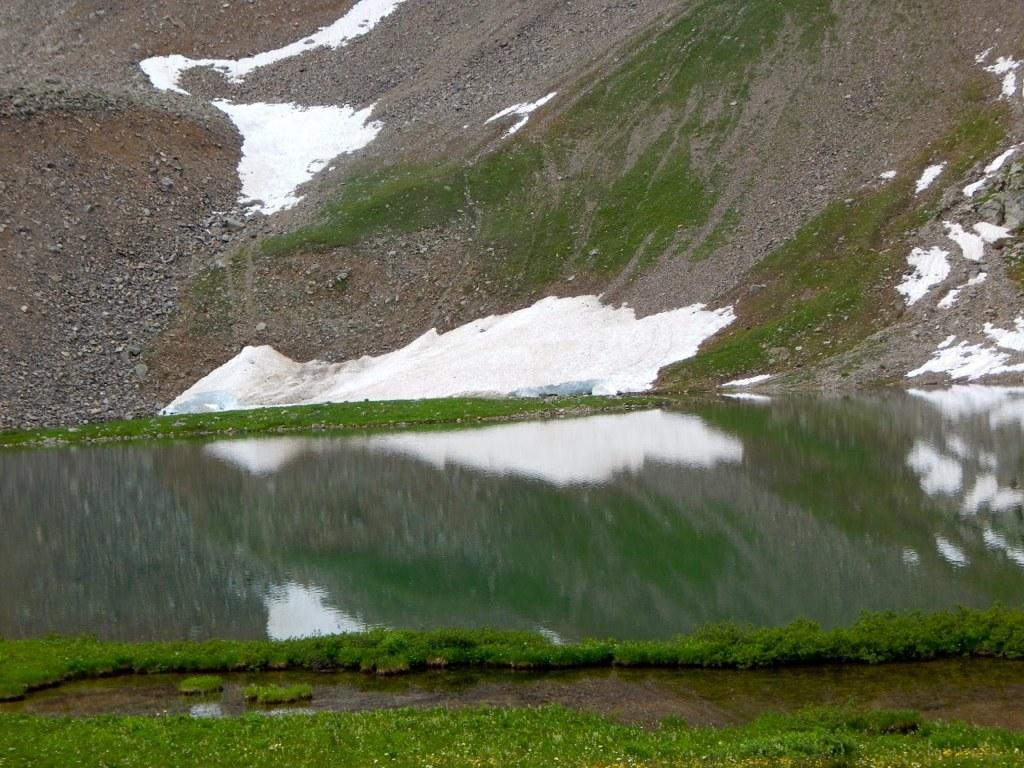What is the main feature in the middle of the image? There is a lake in the middle of the image. What type of terrain is visible in front of the lake? There is grassland in front of the lake. What is located behind the lake? There is a hill behind the lake. What is the condition of the hill? The hill is covered with snow and also has grass on it. What type of gate can be seen near the lake in the image? There is no gate visible near the lake in the image. What month is it in the image? The image does not provide information about the month or time of year. 